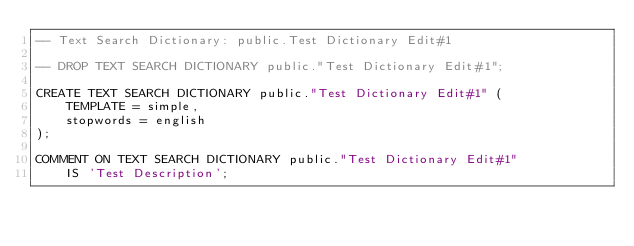<code> <loc_0><loc_0><loc_500><loc_500><_SQL_>-- Text Search Dictionary: public.Test Dictionary Edit#1

-- DROP TEXT SEARCH DICTIONARY public."Test Dictionary Edit#1";

CREATE TEXT SEARCH DICTIONARY public."Test Dictionary Edit#1" (
    TEMPLATE = simple,
    stopwords = english
);

COMMENT ON TEXT SEARCH DICTIONARY public."Test Dictionary Edit#1"
    IS 'Test Description';
</code> 